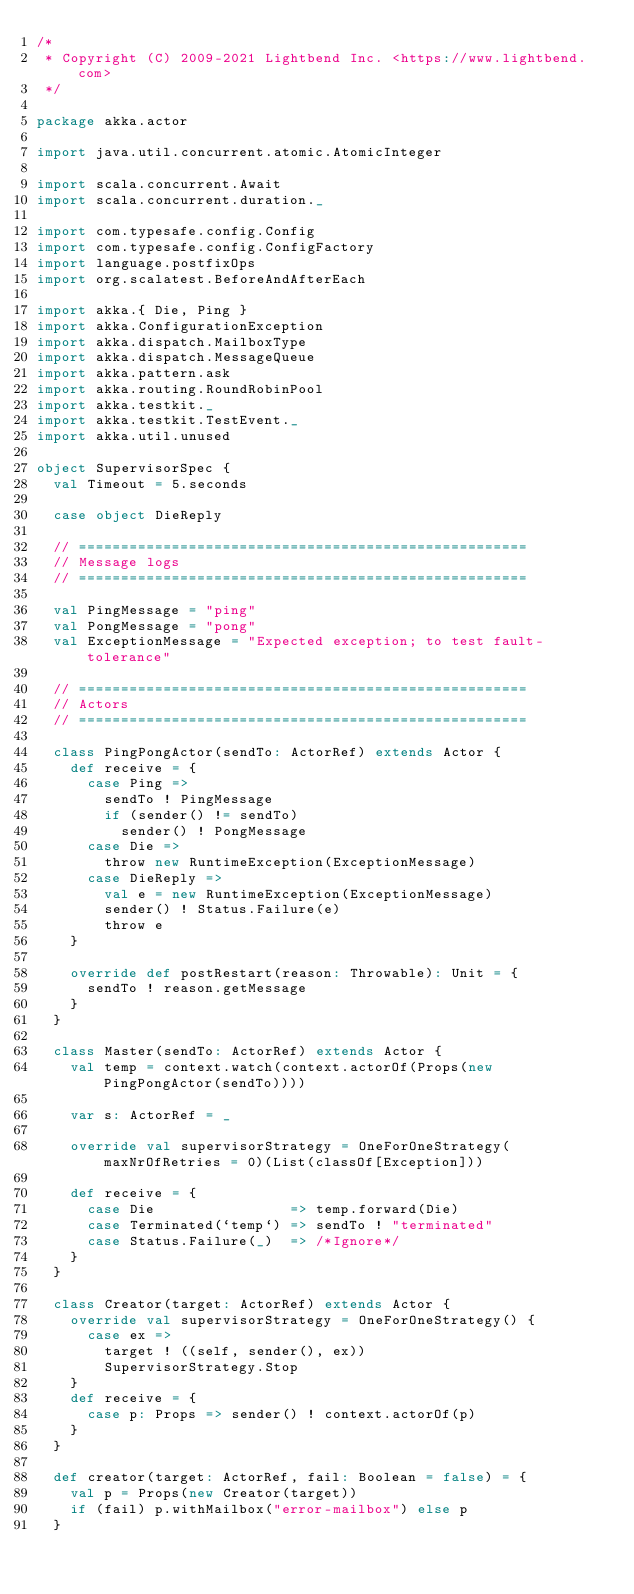Convert code to text. <code><loc_0><loc_0><loc_500><loc_500><_Scala_>/*
 * Copyright (C) 2009-2021 Lightbend Inc. <https://www.lightbend.com>
 */

package akka.actor

import java.util.concurrent.atomic.AtomicInteger

import scala.concurrent.Await
import scala.concurrent.duration._

import com.typesafe.config.Config
import com.typesafe.config.ConfigFactory
import language.postfixOps
import org.scalatest.BeforeAndAfterEach

import akka.{ Die, Ping }
import akka.ConfigurationException
import akka.dispatch.MailboxType
import akka.dispatch.MessageQueue
import akka.pattern.ask
import akka.routing.RoundRobinPool
import akka.testkit._
import akka.testkit.TestEvent._
import akka.util.unused

object SupervisorSpec {
  val Timeout = 5.seconds

  case object DieReply

  // =====================================================
  // Message logs
  // =====================================================

  val PingMessage = "ping"
  val PongMessage = "pong"
  val ExceptionMessage = "Expected exception; to test fault-tolerance"

  // =====================================================
  // Actors
  // =====================================================

  class PingPongActor(sendTo: ActorRef) extends Actor {
    def receive = {
      case Ping =>
        sendTo ! PingMessage
        if (sender() != sendTo)
          sender() ! PongMessage
      case Die =>
        throw new RuntimeException(ExceptionMessage)
      case DieReply =>
        val e = new RuntimeException(ExceptionMessage)
        sender() ! Status.Failure(e)
        throw e
    }

    override def postRestart(reason: Throwable): Unit = {
      sendTo ! reason.getMessage
    }
  }

  class Master(sendTo: ActorRef) extends Actor {
    val temp = context.watch(context.actorOf(Props(new PingPongActor(sendTo))))

    var s: ActorRef = _

    override val supervisorStrategy = OneForOneStrategy(maxNrOfRetries = 0)(List(classOf[Exception]))

    def receive = {
      case Die                => temp.forward(Die)
      case Terminated(`temp`) => sendTo ! "terminated"
      case Status.Failure(_)  => /*Ignore*/
    }
  }

  class Creator(target: ActorRef) extends Actor {
    override val supervisorStrategy = OneForOneStrategy() {
      case ex =>
        target ! ((self, sender(), ex))
        SupervisorStrategy.Stop
    }
    def receive = {
      case p: Props => sender() ! context.actorOf(p)
    }
  }

  def creator(target: ActorRef, fail: Boolean = false) = {
    val p = Props(new Creator(target))
    if (fail) p.withMailbox("error-mailbox") else p
  }
</code> 